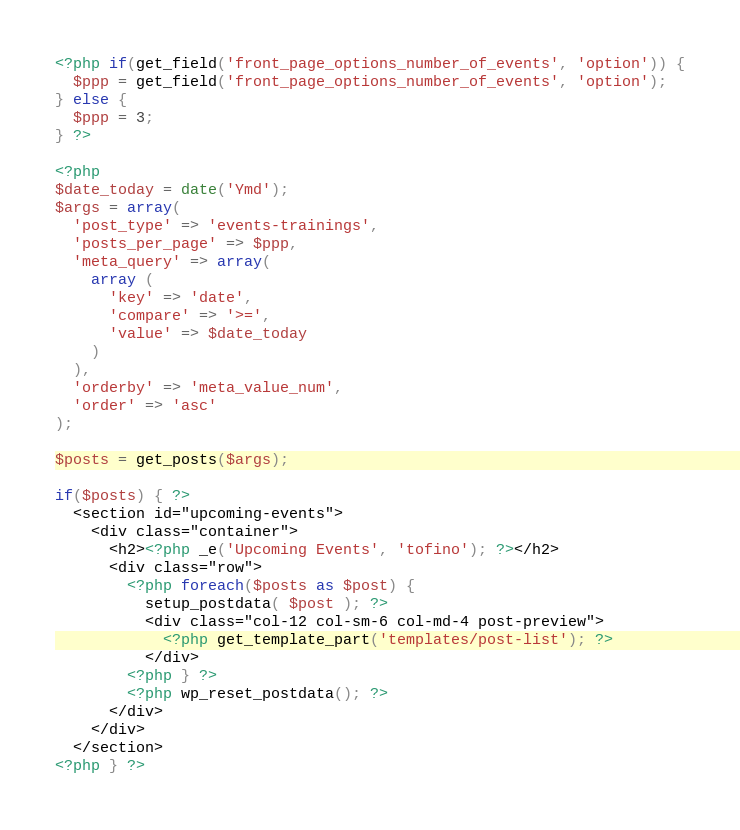Convert code to text. <code><loc_0><loc_0><loc_500><loc_500><_PHP_><?php if(get_field('front_page_options_number_of_events', 'option')) {
  $ppp = get_field('front_page_options_number_of_events', 'option');
} else {
  $ppp = 3;
} ?>

<?php
$date_today = date('Ymd');
$args = array(
  'post_type' => 'events-trainings',
  'posts_per_page' => $ppp,
  'meta_query' => array(
    array (
      'key' => 'date',
      'compare' => '>=',
      'value' => $date_today
    )
  ),
  'orderby' => 'meta_value_num',
  'order' => 'asc'
);

$posts = get_posts($args);

if($posts) { ?>
  <section id="upcoming-events">
    <div class="container">
      <h2><?php _e('Upcoming Events', 'tofino'); ?></h2>
      <div class="row">
        <?php foreach($posts as $post) {
          setup_postdata( $post ); ?>
          <div class="col-12 col-sm-6 col-md-4 post-preview">
            <?php get_template_part('templates/post-list'); ?>
          </div>
        <?php } ?>
        <?php wp_reset_postdata(); ?>
      </div>
    </div>
  </section>
<?php } ?>
</code> 